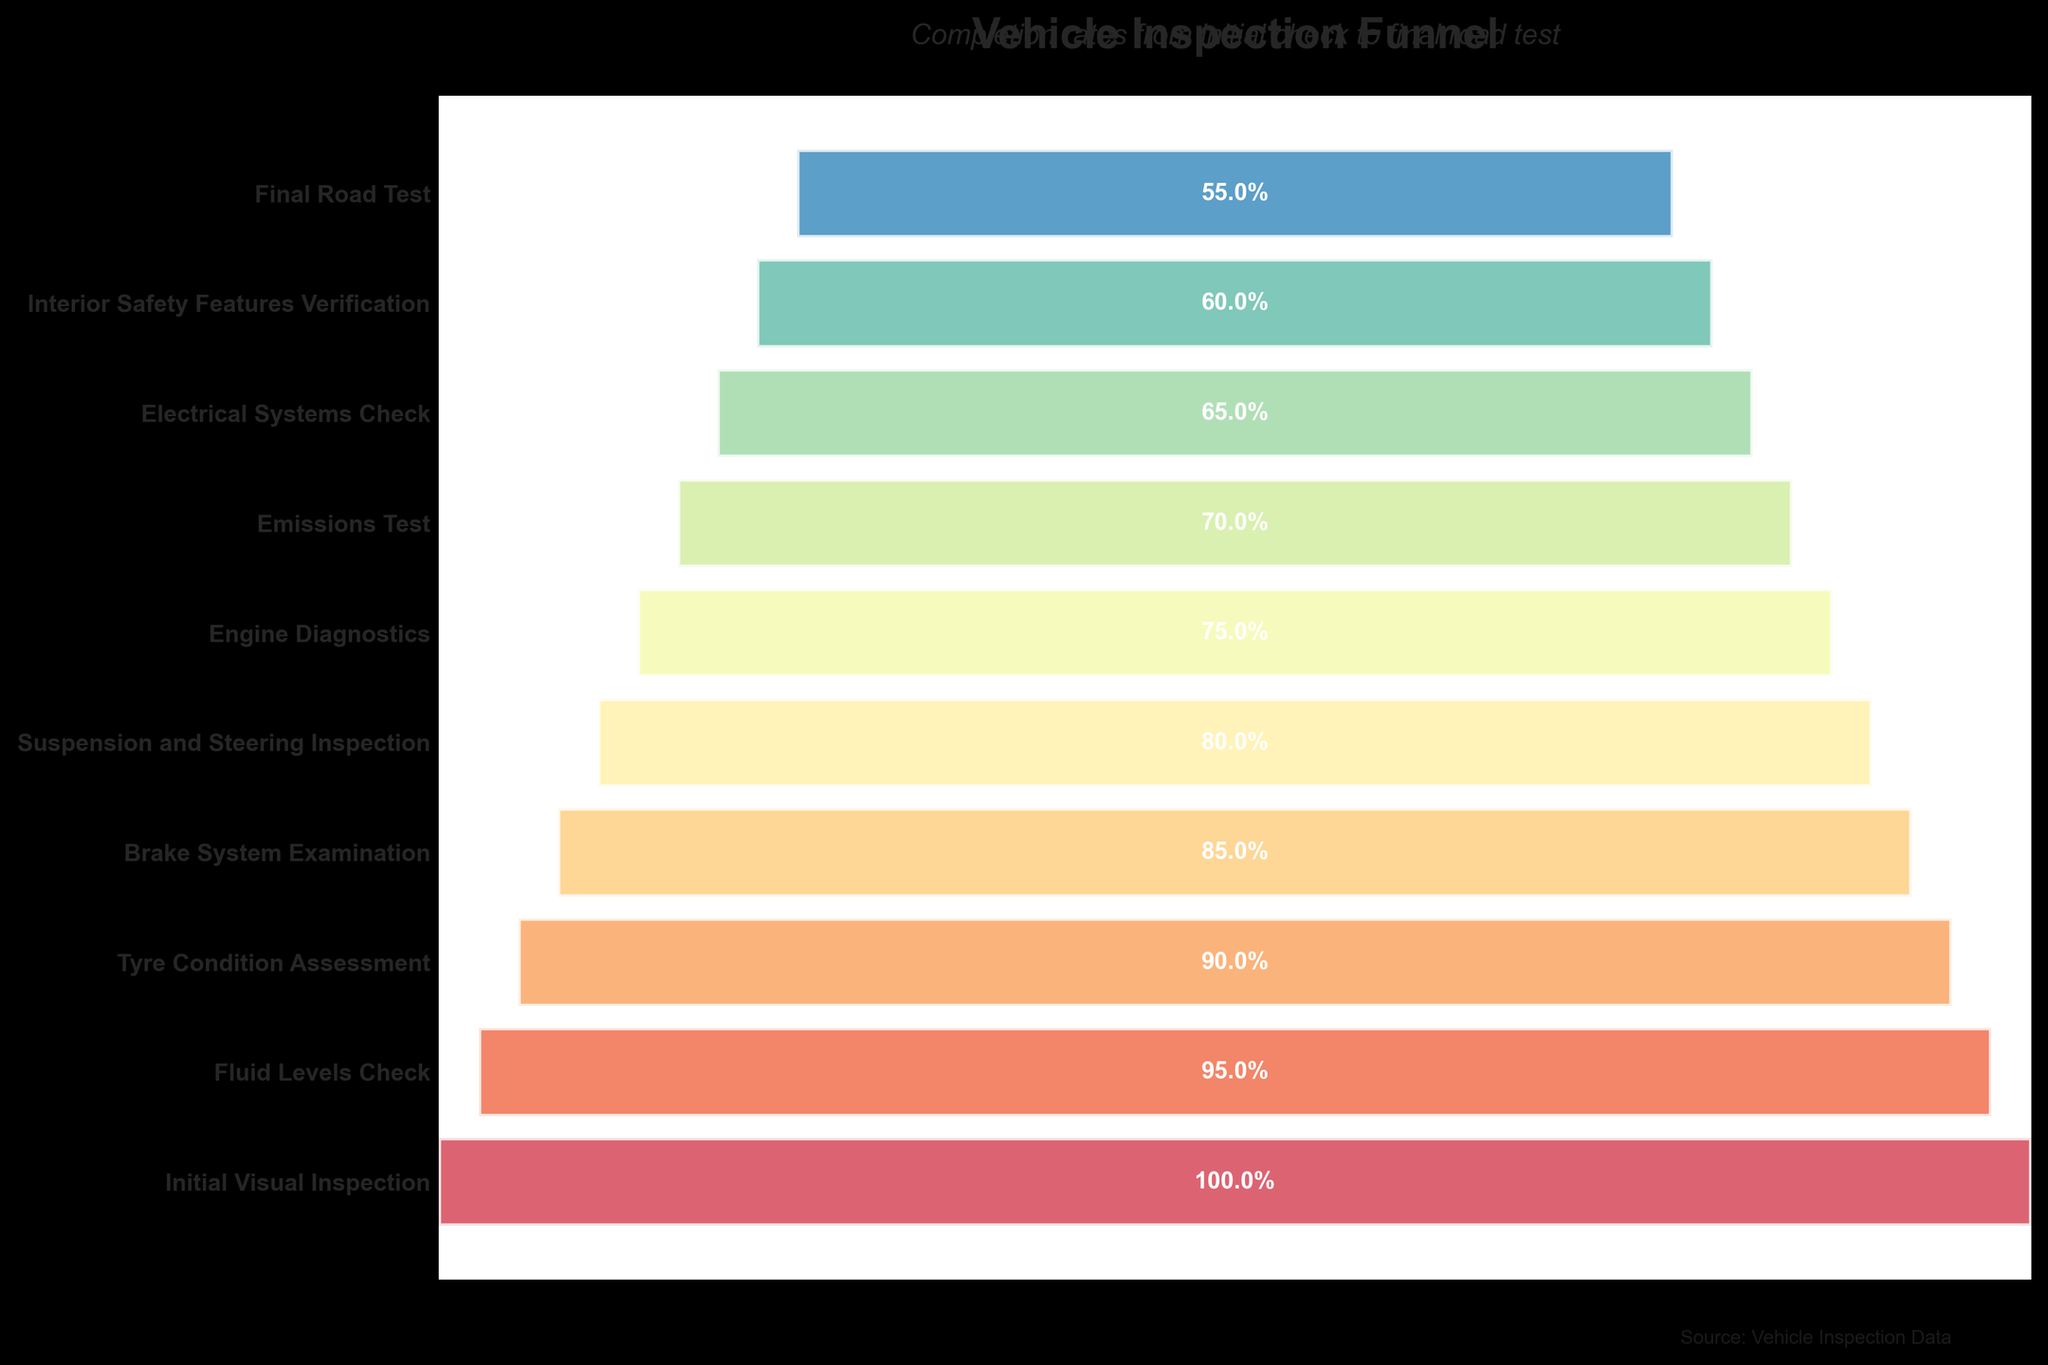What is the title of the figure? The title is usually the most prominent text at the top of the figure. It helps in understanding what the chart represents. The title here is "Vehicle Inspection Funnel."
Answer: Vehicle Inspection Funnel What is the percentage of vehicles that pass the Initial Visual Inspection? Look at the section labeled "Initial Visual Inspection." The percentage value located within this section is 100%.
Answer: 100% Which inspection stage has the lowest completion rate? Check for the stage with the smallest percentage value on the chart. Here, it is the "Final Road Test" with 55%.
Answer: Final Road Test What is the difference in vehicle percentage between the Brake System Examination and the Final Road Test? Subtract the percentage of the Final Road Test (55%) from the Brake System Examination (85%). Calculation: 85% - 55% = 30%.
Answer: 30% Which stage sees a 15% drop from the previous stage? Locate the consecutive stages where the percentage difference equals 15%. Here, it is from "Fluid Levels Check" (95%) to "Tyre Condition Assessment" (90%), and from "Suspension and Steering Inspection" (80%) to "Engine Diagnostics" (75%).
Answer: Fluid Levels Check to Tyre Condition Assessment or Suspension and Steering Inspection to Engine Diagnostics What percentage of vehicles fail the Engine Diagnostics? Calculate the difference between 100% and the percentage of vehicles that pass the Engine Diagnostics (75%). Thus, 100% - 75% = 25%.
Answer: 25% How many stages see a drop of at least 5% from the previous stage? Count the stages where the percentage drop from the previous stage is 5% or more. Here, every consecutive stage has a drop of at least 5%, totaling 9 stages.
Answer: 9 Compare the percentage of vehicles passing the Emissions Test to those passing the Electrical Systems Check. Find the percentage values for both stages. Emissions Test has 70%, and Electrical Systems Check has 65%. Emissions Test has a higher percentage.
Answer: Emissions Test is higher Considering the trend, if 550 vehicles were initially inspected, how many would you expect to pass the Final Road Test? Use the current completion rate at each stage to estimate the value. Final Road Test completion rate is 55%. Calculation: 550 * 55% = 302.5, approximately 303 vehicles.
Answer: 303 